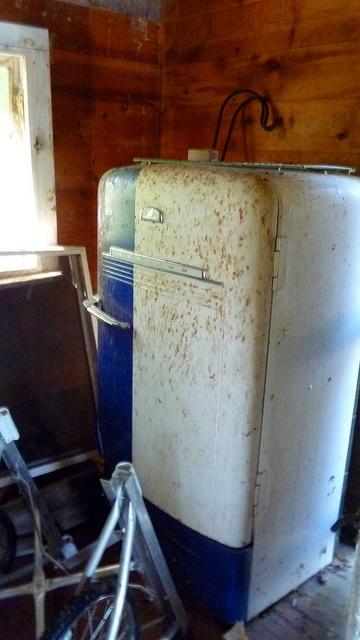What colors  on the fridge?
Short answer required. White and blue. Does the device keep things cold?
Answer briefly. Yes. Is this refrigerator a new model?
Keep it brief. No. Is this a new refrigerator?
Give a very brief answer. No. 